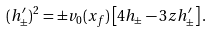Convert formula to latex. <formula><loc_0><loc_0><loc_500><loc_500>( h _ { \pm } ^ { \prime } ) ^ { 2 } = \pm v _ { 0 } ( x _ { f } ) \left [ 4 h _ { \pm } - 3 z h _ { \pm } ^ { \prime } \right ] .</formula> 